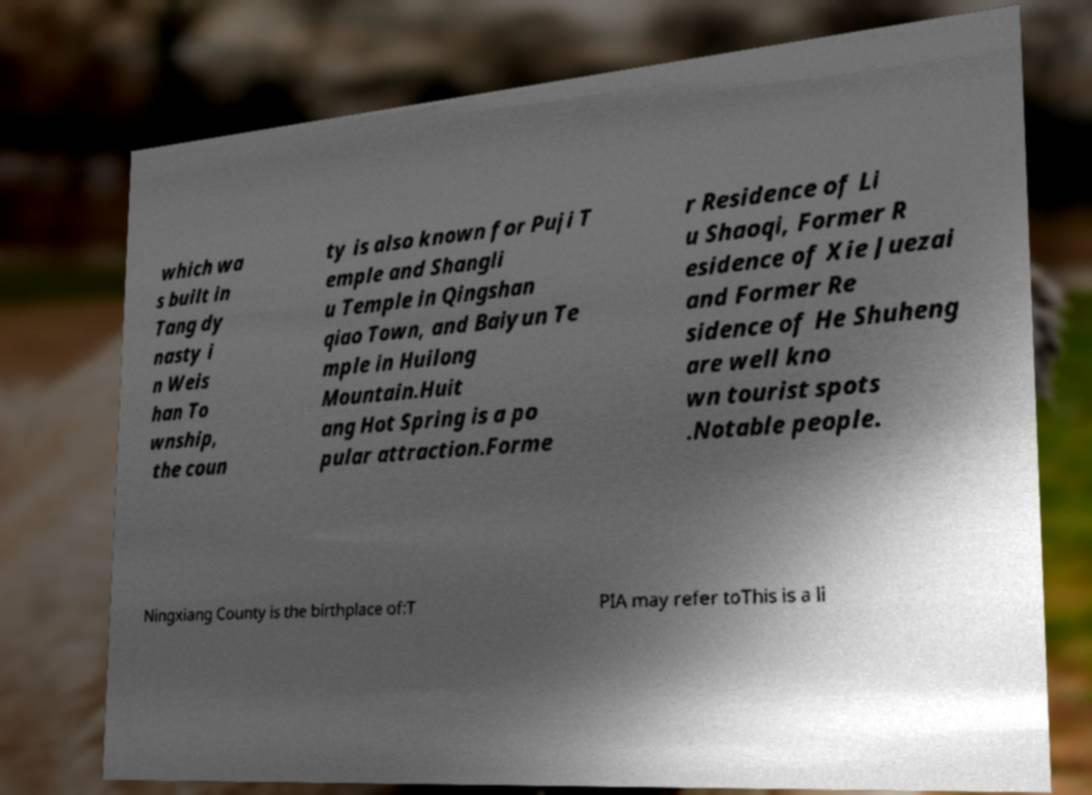What messages or text are displayed in this image? I need them in a readable, typed format. which wa s built in Tang dy nasty i n Weis han To wnship, the coun ty is also known for Puji T emple and Shangli u Temple in Qingshan qiao Town, and Baiyun Te mple in Huilong Mountain.Huit ang Hot Spring is a po pular attraction.Forme r Residence of Li u Shaoqi, Former R esidence of Xie Juezai and Former Re sidence of He Shuheng are well kno wn tourist spots .Notable people. Ningxiang County is the birthplace of:T PIA may refer toThis is a li 